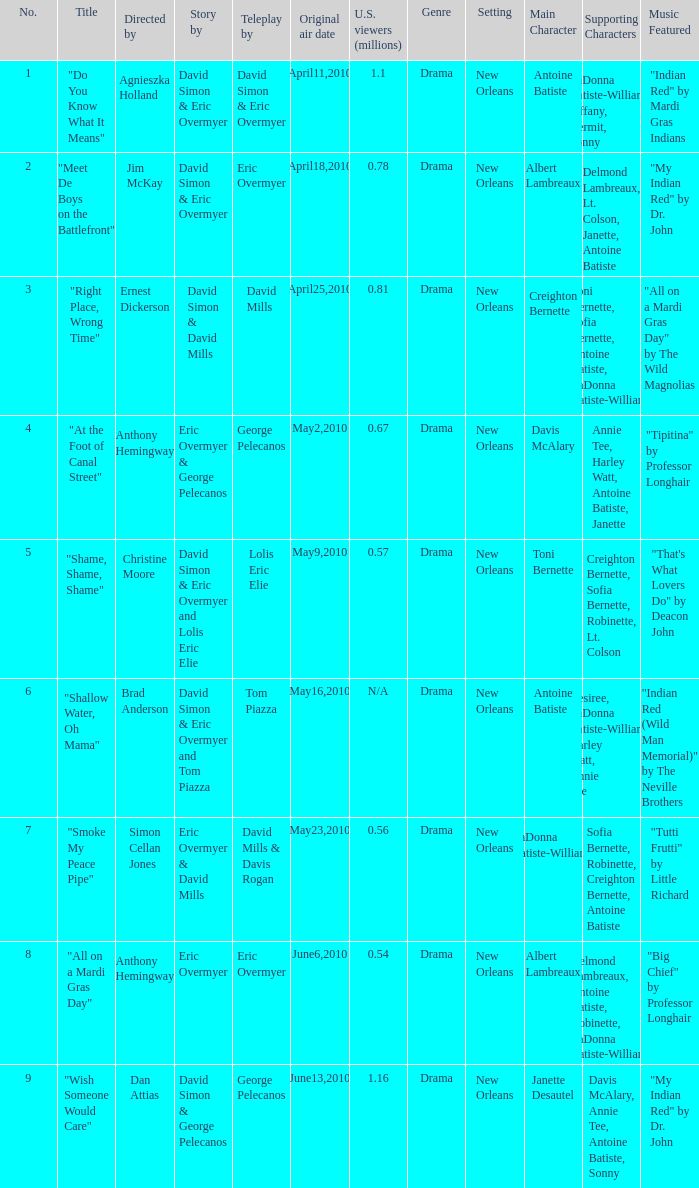Name the most number 9.0. 